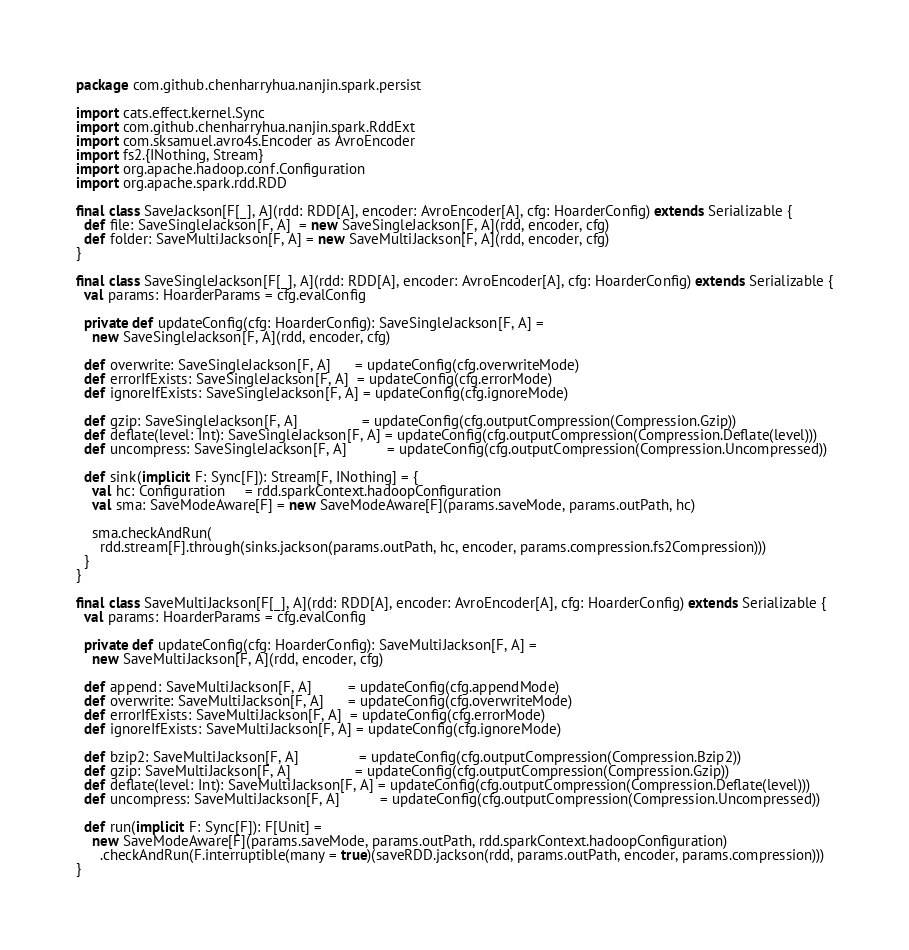<code> <loc_0><loc_0><loc_500><loc_500><_Scala_>package com.github.chenharryhua.nanjin.spark.persist

import cats.effect.kernel.Sync
import com.github.chenharryhua.nanjin.spark.RddExt
import com.sksamuel.avro4s.Encoder as AvroEncoder
import fs2.{INothing, Stream}
import org.apache.hadoop.conf.Configuration
import org.apache.spark.rdd.RDD

final class SaveJackson[F[_], A](rdd: RDD[A], encoder: AvroEncoder[A], cfg: HoarderConfig) extends Serializable {
  def file: SaveSingleJackson[F, A]  = new SaveSingleJackson[F, A](rdd, encoder, cfg)
  def folder: SaveMultiJackson[F, A] = new SaveMultiJackson[F, A](rdd, encoder, cfg)
}

final class SaveSingleJackson[F[_], A](rdd: RDD[A], encoder: AvroEncoder[A], cfg: HoarderConfig) extends Serializable {
  val params: HoarderParams = cfg.evalConfig

  private def updateConfig(cfg: HoarderConfig): SaveSingleJackson[F, A] =
    new SaveSingleJackson[F, A](rdd, encoder, cfg)

  def overwrite: SaveSingleJackson[F, A]      = updateConfig(cfg.overwriteMode)
  def errorIfExists: SaveSingleJackson[F, A]  = updateConfig(cfg.errorMode)
  def ignoreIfExists: SaveSingleJackson[F, A] = updateConfig(cfg.ignoreMode)

  def gzip: SaveSingleJackson[F, A]                = updateConfig(cfg.outputCompression(Compression.Gzip))
  def deflate(level: Int): SaveSingleJackson[F, A] = updateConfig(cfg.outputCompression(Compression.Deflate(level)))
  def uncompress: SaveSingleJackson[F, A]          = updateConfig(cfg.outputCompression(Compression.Uncompressed))

  def sink(implicit F: Sync[F]): Stream[F, INothing] = {
    val hc: Configuration     = rdd.sparkContext.hadoopConfiguration
    val sma: SaveModeAware[F] = new SaveModeAware[F](params.saveMode, params.outPath, hc)

    sma.checkAndRun(
      rdd.stream[F].through(sinks.jackson(params.outPath, hc, encoder, params.compression.fs2Compression)))
  }
}

final class SaveMultiJackson[F[_], A](rdd: RDD[A], encoder: AvroEncoder[A], cfg: HoarderConfig) extends Serializable {
  val params: HoarderParams = cfg.evalConfig

  private def updateConfig(cfg: HoarderConfig): SaveMultiJackson[F, A] =
    new SaveMultiJackson[F, A](rdd, encoder, cfg)

  def append: SaveMultiJackson[F, A]         = updateConfig(cfg.appendMode)
  def overwrite: SaveMultiJackson[F, A]      = updateConfig(cfg.overwriteMode)
  def errorIfExists: SaveMultiJackson[F, A]  = updateConfig(cfg.errorMode)
  def ignoreIfExists: SaveMultiJackson[F, A] = updateConfig(cfg.ignoreMode)

  def bzip2: SaveMultiJackson[F, A]               = updateConfig(cfg.outputCompression(Compression.Bzip2))
  def gzip: SaveMultiJackson[F, A]                = updateConfig(cfg.outputCompression(Compression.Gzip))
  def deflate(level: Int): SaveMultiJackson[F, A] = updateConfig(cfg.outputCompression(Compression.Deflate(level)))
  def uncompress: SaveMultiJackson[F, A]          = updateConfig(cfg.outputCompression(Compression.Uncompressed))

  def run(implicit F: Sync[F]): F[Unit] =
    new SaveModeAware[F](params.saveMode, params.outPath, rdd.sparkContext.hadoopConfiguration)
      .checkAndRun(F.interruptible(many = true)(saveRDD.jackson(rdd, params.outPath, encoder, params.compression)))
}
</code> 